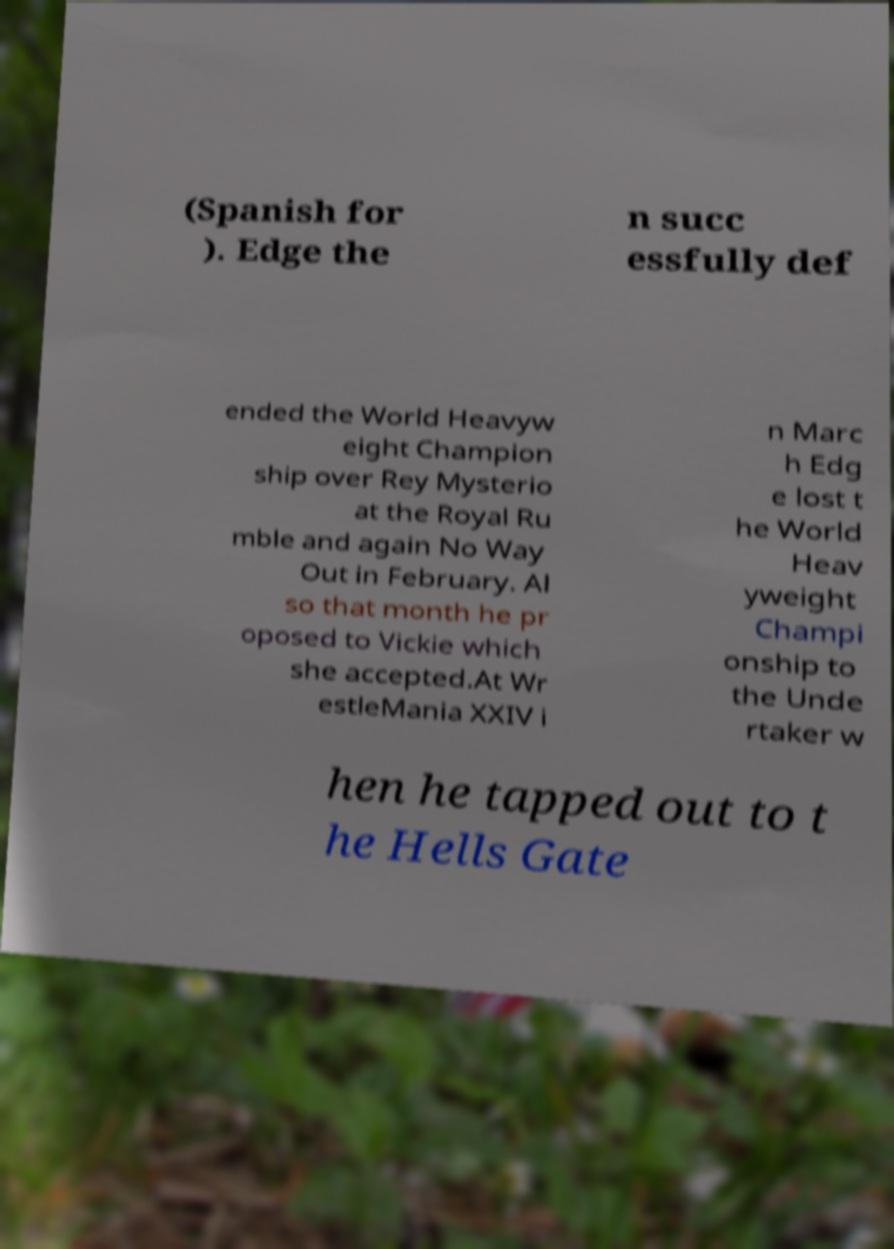Could you assist in decoding the text presented in this image and type it out clearly? (Spanish for ). Edge the n succ essfully def ended the World Heavyw eight Champion ship over Rey Mysterio at the Royal Ru mble and again No Way Out in February. Al so that month he pr oposed to Vickie which she accepted.At Wr estleMania XXIV i n Marc h Edg e lost t he World Heav yweight Champi onship to the Unde rtaker w hen he tapped out to t he Hells Gate 